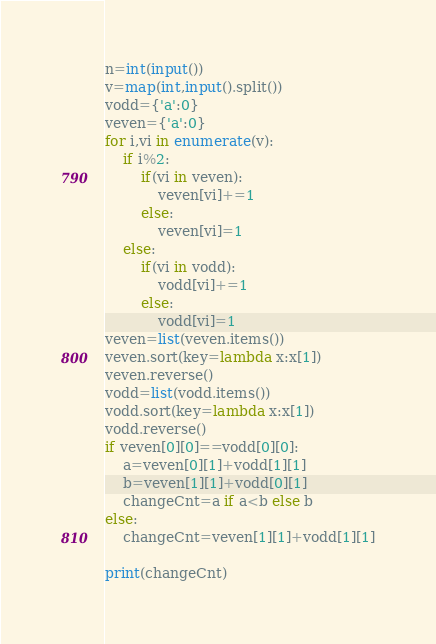Convert code to text. <code><loc_0><loc_0><loc_500><loc_500><_Python_>
n=int(input())
v=map(int,input().split())
vodd={'a':0}
veven={'a':0}
for i,vi in enumerate(v):
    if i%2:
        if(vi in veven):
            veven[vi]+=1
        else:
            veven[vi]=1
    else:
        if(vi in vodd):
            vodd[vi]+=1
        else:
            vodd[vi]=1
veven=list(veven.items())
veven.sort(key=lambda x:x[1])
veven.reverse()
vodd=list(vodd.items())
vodd.sort(key=lambda x:x[1])
vodd.reverse()
if veven[0][0]==vodd[0][0]:
    a=veven[0][1]+vodd[1][1]
    b=veven[1][1]+vodd[0][1]
    changeCnt=a if a<b else b
else:
    changeCnt=veven[1][1]+vodd[1][1]

print(changeCnt)</code> 